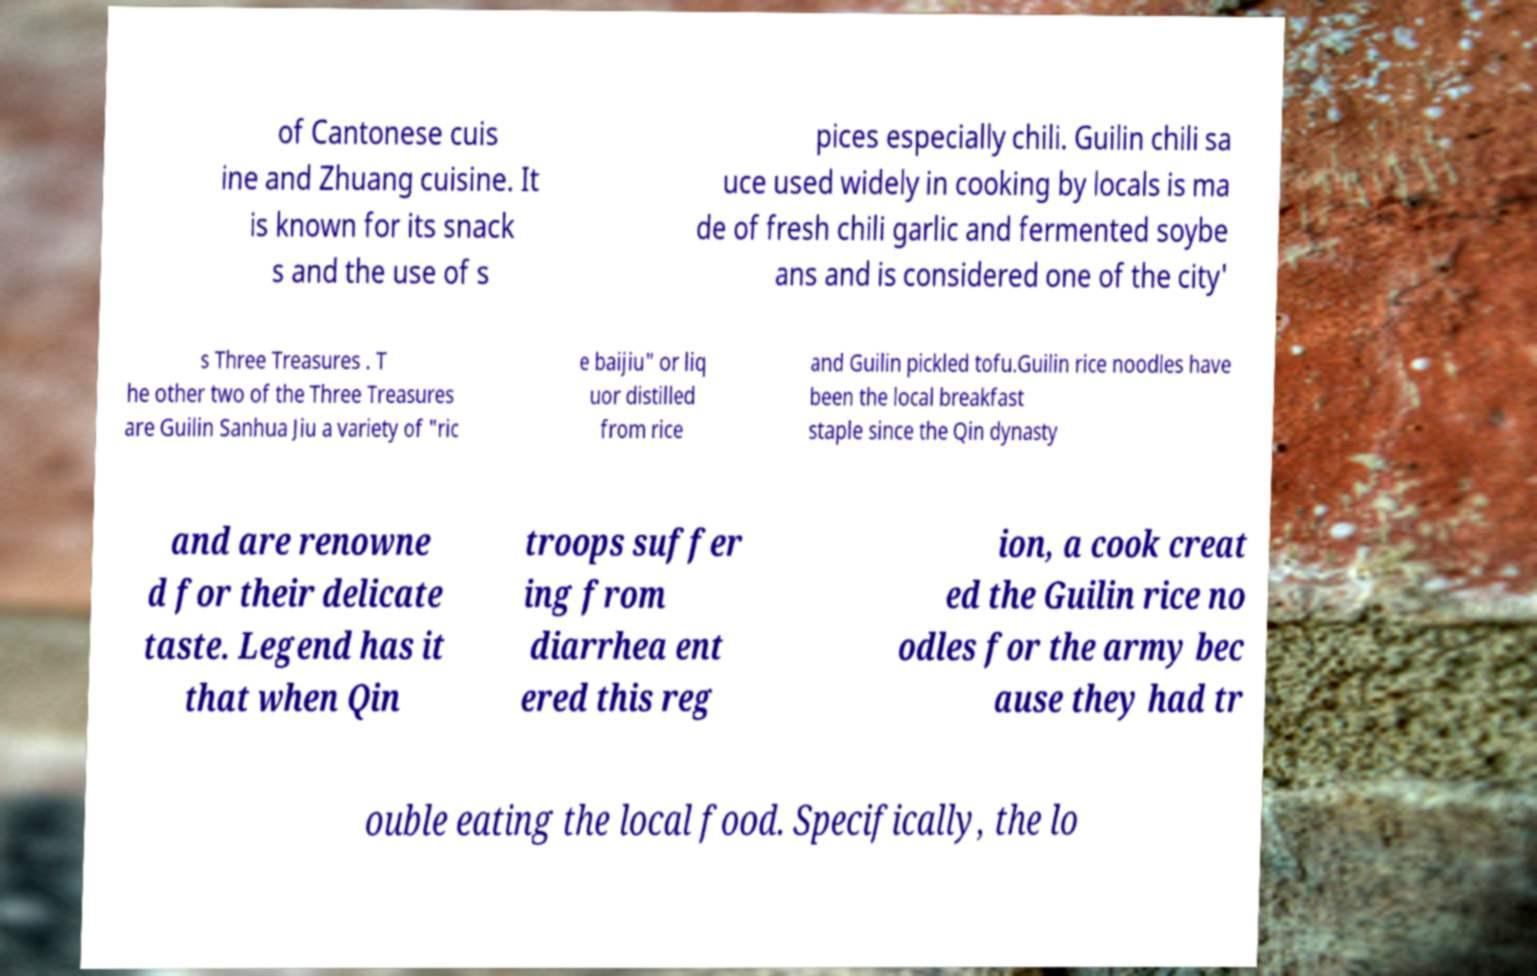Can you read and provide the text displayed in the image?This photo seems to have some interesting text. Can you extract and type it out for me? of Cantonese cuis ine and Zhuang cuisine. It is known for its snack s and the use of s pices especially chili. Guilin chili sa uce used widely in cooking by locals is ma de of fresh chili garlic and fermented soybe ans and is considered one of the city' s Three Treasures . T he other two of the Three Treasures are Guilin Sanhua Jiu a variety of "ric e baijiu" or liq uor distilled from rice and Guilin pickled tofu.Guilin rice noodles have been the local breakfast staple since the Qin dynasty and are renowne d for their delicate taste. Legend has it that when Qin troops suffer ing from diarrhea ent ered this reg ion, a cook creat ed the Guilin rice no odles for the army bec ause they had tr ouble eating the local food. Specifically, the lo 